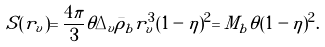Convert formula to latex. <formula><loc_0><loc_0><loc_500><loc_500>S ( r _ { v } ) = \frac { 4 \pi } { 3 } \theta \Delta _ { v } \bar { \rho } _ { b } r _ { v } ^ { 3 } ( 1 - \eta ) ^ { 2 } = M _ { b } \theta ( 1 - \eta ) ^ { 2 } .</formula> 